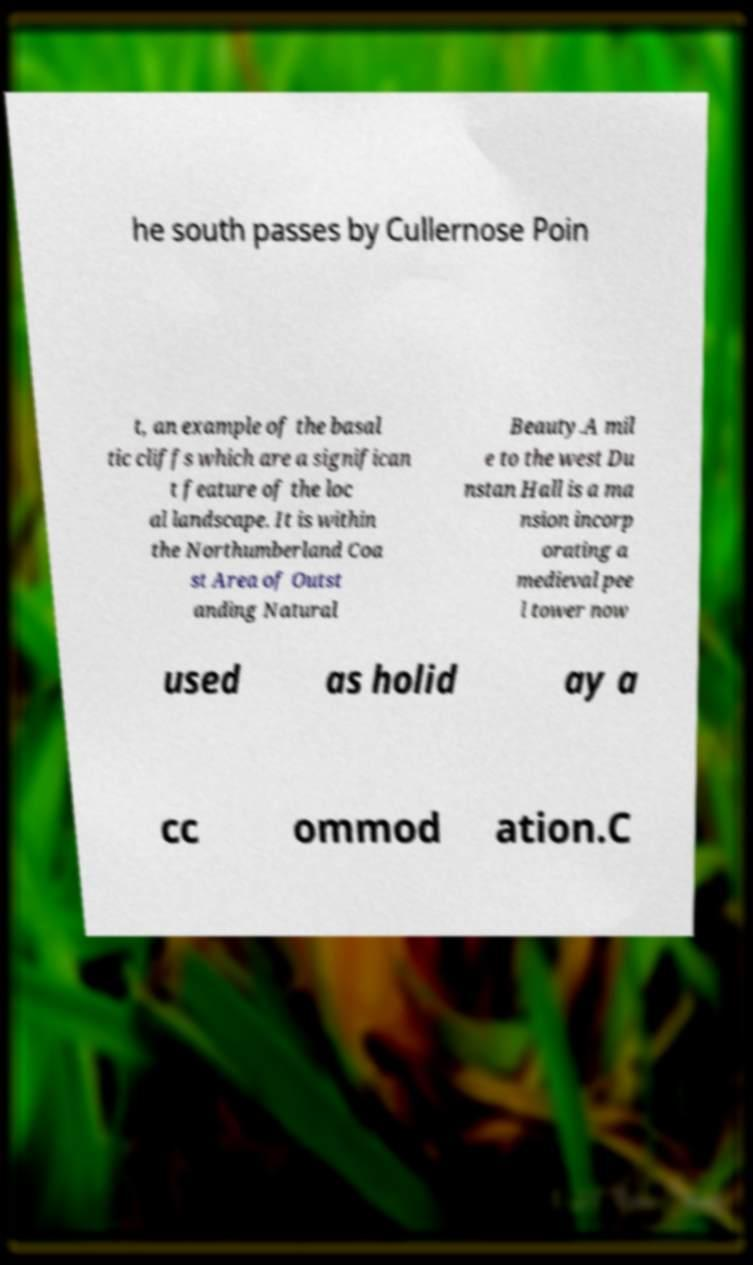What messages or text are displayed in this image? I need them in a readable, typed format. he south passes by Cullernose Poin t, an example of the basal tic cliffs which are a significan t feature of the loc al landscape. It is within the Northumberland Coa st Area of Outst anding Natural Beauty.A mil e to the west Du nstan Hall is a ma nsion incorp orating a medieval pee l tower now used as holid ay a cc ommod ation.C 